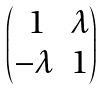Convert formula to latex. <formula><loc_0><loc_0><loc_500><loc_500>\begin{pmatrix} \, 1 & \lambda \\ - \lambda & 1 \end{pmatrix}</formula> 